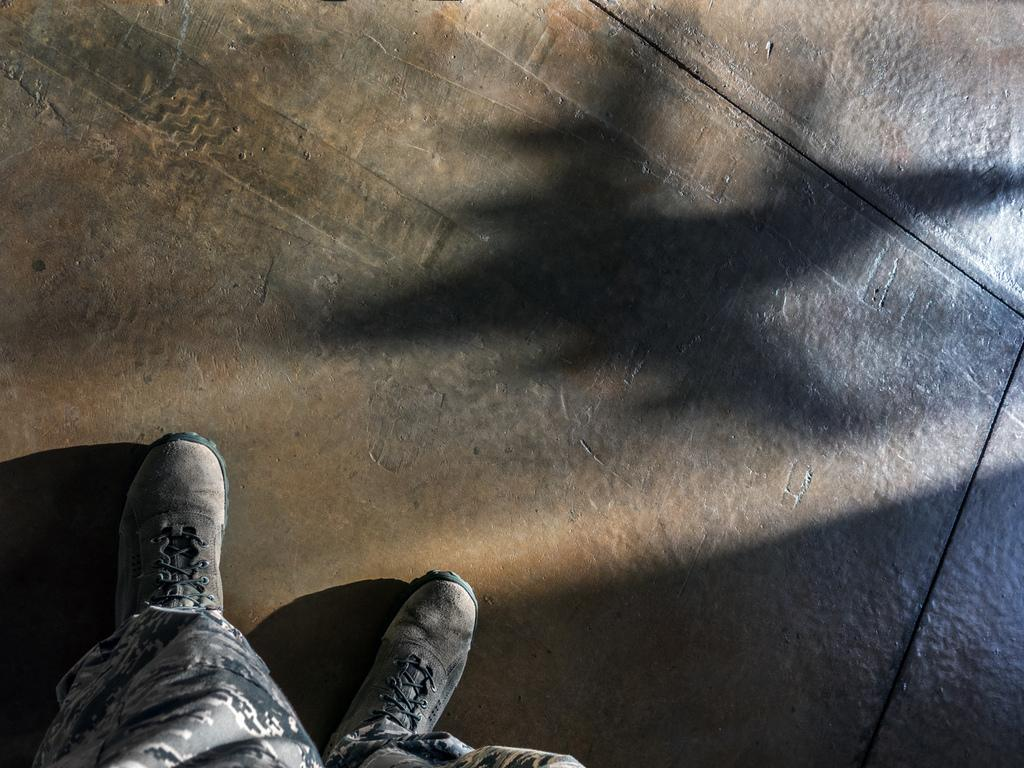What body parts are visible in the image? There are persons' legs visible in the image. What type of surface can be seen beneath the legs? There is flooring in the image. What type of watch is the person wearing on their nail in the image? There is no watch or nail visible in the image; only persons' legs and flooring are present. 